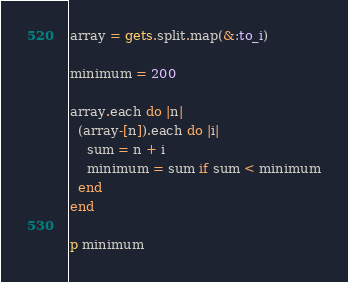Convert code to text. <code><loc_0><loc_0><loc_500><loc_500><_Ruby_>array = gets.split.map(&:to_i)

minimum = 200

array.each do |n|
  (array-[n]).each do |i|
    sum = n + i
    minimum = sum if sum < minimum
  end
end

p minimum</code> 